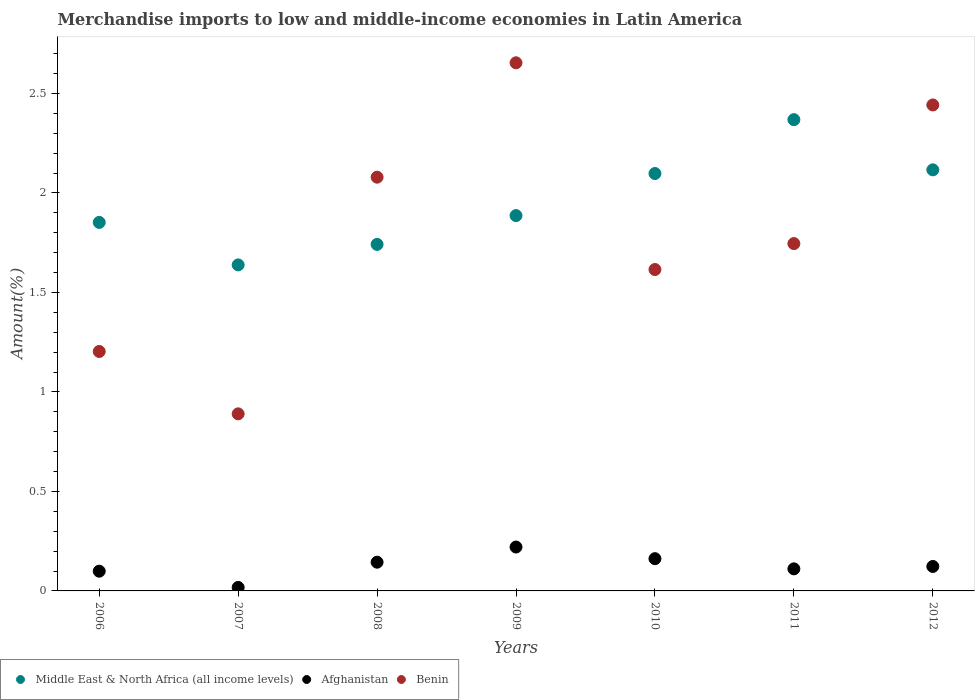How many different coloured dotlines are there?
Your answer should be compact. 3. Is the number of dotlines equal to the number of legend labels?
Make the answer very short. Yes. What is the percentage of amount earned from merchandise imports in Middle East & North Africa (all income levels) in 2006?
Ensure brevity in your answer.  1.85. Across all years, what is the maximum percentage of amount earned from merchandise imports in Afghanistan?
Your response must be concise. 0.22. Across all years, what is the minimum percentage of amount earned from merchandise imports in Afghanistan?
Keep it short and to the point. 0.02. In which year was the percentage of amount earned from merchandise imports in Afghanistan maximum?
Give a very brief answer. 2009. In which year was the percentage of amount earned from merchandise imports in Afghanistan minimum?
Provide a short and direct response. 2007. What is the total percentage of amount earned from merchandise imports in Afghanistan in the graph?
Your answer should be very brief. 0.88. What is the difference between the percentage of amount earned from merchandise imports in Afghanistan in 2008 and that in 2011?
Your response must be concise. 0.03. What is the difference between the percentage of amount earned from merchandise imports in Afghanistan in 2006 and the percentage of amount earned from merchandise imports in Benin in 2007?
Make the answer very short. -0.79. What is the average percentage of amount earned from merchandise imports in Benin per year?
Your answer should be compact. 1.8. In the year 2011, what is the difference between the percentage of amount earned from merchandise imports in Middle East & North Africa (all income levels) and percentage of amount earned from merchandise imports in Afghanistan?
Offer a very short reply. 2.26. In how many years, is the percentage of amount earned from merchandise imports in Middle East & North Africa (all income levels) greater than 1.5 %?
Ensure brevity in your answer.  7. What is the ratio of the percentage of amount earned from merchandise imports in Middle East & North Africa (all income levels) in 2009 to that in 2010?
Provide a succinct answer. 0.9. Is the difference between the percentage of amount earned from merchandise imports in Middle East & North Africa (all income levels) in 2010 and 2012 greater than the difference between the percentage of amount earned from merchandise imports in Afghanistan in 2010 and 2012?
Your answer should be compact. No. What is the difference between the highest and the second highest percentage of amount earned from merchandise imports in Benin?
Provide a succinct answer. 0.21. What is the difference between the highest and the lowest percentage of amount earned from merchandise imports in Middle East & North Africa (all income levels)?
Offer a terse response. 0.73. In how many years, is the percentage of amount earned from merchandise imports in Benin greater than the average percentage of amount earned from merchandise imports in Benin taken over all years?
Offer a very short reply. 3. Is it the case that in every year, the sum of the percentage of amount earned from merchandise imports in Benin and percentage of amount earned from merchandise imports in Middle East & North Africa (all income levels)  is greater than the percentage of amount earned from merchandise imports in Afghanistan?
Keep it short and to the point. Yes. Does the percentage of amount earned from merchandise imports in Benin monotonically increase over the years?
Your answer should be compact. No. Is the percentage of amount earned from merchandise imports in Benin strictly greater than the percentage of amount earned from merchandise imports in Afghanistan over the years?
Offer a terse response. Yes. Is the percentage of amount earned from merchandise imports in Middle East & North Africa (all income levels) strictly less than the percentage of amount earned from merchandise imports in Benin over the years?
Make the answer very short. No. How many dotlines are there?
Provide a succinct answer. 3. What is the difference between two consecutive major ticks on the Y-axis?
Provide a short and direct response. 0.5. Are the values on the major ticks of Y-axis written in scientific E-notation?
Keep it short and to the point. No. Does the graph contain grids?
Make the answer very short. No. Where does the legend appear in the graph?
Provide a short and direct response. Bottom left. How many legend labels are there?
Provide a succinct answer. 3. How are the legend labels stacked?
Provide a succinct answer. Horizontal. What is the title of the graph?
Your answer should be very brief. Merchandise imports to low and middle-income economies in Latin America. What is the label or title of the X-axis?
Your response must be concise. Years. What is the label or title of the Y-axis?
Your answer should be compact. Amount(%). What is the Amount(%) of Middle East & North Africa (all income levels) in 2006?
Your answer should be compact. 1.85. What is the Amount(%) of Afghanistan in 2006?
Provide a succinct answer. 0.1. What is the Amount(%) in Benin in 2006?
Provide a short and direct response. 1.2. What is the Amount(%) of Middle East & North Africa (all income levels) in 2007?
Ensure brevity in your answer.  1.64. What is the Amount(%) in Afghanistan in 2007?
Offer a terse response. 0.02. What is the Amount(%) in Benin in 2007?
Ensure brevity in your answer.  0.89. What is the Amount(%) of Middle East & North Africa (all income levels) in 2008?
Offer a terse response. 1.74. What is the Amount(%) in Afghanistan in 2008?
Provide a succinct answer. 0.14. What is the Amount(%) in Benin in 2008?
Offer a very short reply. 2.08. What is the Amount(%) of Middle East & North Africa (all income levels) in 2009?
Ensure brevity in your answer.  1.89. What is the Amount(%) in Afghanistan in 2009?
Ensure brevity in your answer.  0.22. What is the Amount(%) in Benin in 2009?
Give a very brief answer. 2.65. What is the Amount(%) in Middle East & North Africa (all income levels) in 2010?
Your answer should be compact. 2.1. What is the Amount(%) of Afghanistan in 2010?
Give a very brief answer. 0.16. What is the Amount(%) of Benin in 2010?
Offer a terse response. 1.62. What is the Amount(%) in Middle East & North Africa (all income levels) in 2011?
Your response must be concise. 2.37. What is the Amount(%) in Afghanistan in 2011?
Your answer should be very brief. 0.11. What is the Amount(%) in Benin in 2011?
Provide a succinct answer. 1.75. What is the Amount(%) in Middle East & North Africa (all income levels) in 2012?
Give a very brief answer. 2.12. What is the Amount(%) of Afghanistan in 2012?
Offer a terse response. 0.12. What is the Amount(%) of Benin in 2012?
Your answer should be compact. 2.44. Across all years, what is the maximum Amount(%) of Middle East & North Africa (all income levels)?
Offer a terse response. 2.37. Across all years, what is the maximum Amount(%) of Afghanistan?
Make the answer very short. 0.22. Across all years, what is the maximum Amount(%) in Benin?
Provide a short and direct response. 2.65. Across all years, what is the minimum Amount(%) in Middle East & North Africa (all income levels)?
Your answer should be very brief. 1.64. Across all years, what is the minimum Amount(%) of Afghanistan?
Make the answer very short. 0.02. Across all years, what is the minimum Amount(%) of Benin?
Offer a terse response. 0.89. What is the total Amount(%) in Middle East & North Africa (all income levels) in the graph?
Your response must be concise. 13.7. What is the total Amount(%) of Afghanistan in the graph?
Make the answer very short. 0.88. What is the total Amount(%) in Benin in the graph?
Give a very brief answer. 12.63. What is the difference between the Amount(%) in Middle East & North Africa (all income levels) in 2006 and that in 2007?
Provide a succinct answer. 0.21. What is the difference between the Amount(%) in Afghanistan in 2006 and that in 2007?
Give a very brief answer. 0.08. What is the difference between the Amount(%) of Benin in 2006 and that in 2007?
Provide a short and direct response. 0.31. What is the difference between the Amount(%) in Middle East & North Africa (all income levels) in 2006 and that in 2008?
Make the answer very short. 0.11. What is the difference between the Amount(%) in Afghanistan in 2006 and that in 2008?
Provide a succinct answer. -0.05. What is the difference between the Amount(%) in Benin in 2006 and that in 2008?
Keep it short and to the point. -0.88. What is the difference between the Amount(%) in Middle East & North Africa (all income levels) in 2006 and that in 2009?
Make the answer very short. -0.03. What is the difference between the Amount(%) of Afghanistan in 2006 and that in 2009?
Make the answer very short. -0.12. What is the difference between the Amount(%) in Benin in 2006 and that in 2009?
Keep it short and to the point. -1.45. What is the difference between the Amount(%) in Middle East & North Africa (all income levels) in 2006 and that in 2010?
Give a very brief answer. -0.25. What is the difference between the Amount(%) of Afghanistan in 2006 and that in 2010?
Your response must be concise. -0.06. What is the difference between the Amount(%) in Benin in 2006 and that in 2010?
Offer a very short reply. -0.41. What is the difference between the Amount(%) of Middle East & North Africa (all income levels) in 2006 and that in 2011?
Ensure brevity in your answer.  -0.52. What is the difference between the Amount(%) in Afghanistan in 2006 and that in 2011?
Your answer should be compact. -0.01. What is the difference between the Amount(%) in Benin in 2006 and that in 2011?
Your response must be concise. -0.54. What is the difference between the Amount(%) of Middle East & North Africa (all income levels) in 2006 and that in 2012?
Your answer should be compact. -0.26. What is the difference between the Amount(%) of Afghanistan in 2006 and that in 2012?
Ensure brevity in your answer.  -0.02. What is the difference between the Amount(%) of Benin in 2006 and that in 2012?
Your answer should be compact. -1.24. What is the difference between the Amount(%) in Middle East & North Africa (all income levels) in 2007 and that in 2008?
Your answer should be very brief. -0.1. What is the difference between the Amount(%) of Afghanistan in 2007 and that in 2008?
Keep it short and to the point. -0.13. What is the difference between the Amount(%) of Benin in 2007 and that in 2008?
Provide a short and direct response. -1.19. What is the difference between the Amount(%) of Middle East & North Africa (all income levels) in 2007 and that in 2009?
Ensure brevity in your answer.  -0.25. What is the difference between the Amount(%) in Afghanistan in 2007 and that in 2009?
Provide a short and direct response. -0.2. What is the difference between the Amount(%) in Benin in 2007 and that in 2009?
Your answer should be very brief. -1.76. What is the difference between the Amount(%) in Middle East & North Africa (all income levels) in 2007 and that in 2010?
Your response must be concise. -0.46. What is the difference between the Amount(%) of Afghanistan in 2007 and that in 2010?
Your response must be concise. -0.14. What is the difference between the Amount(%) in Benin in 2007 and that in 2010?
Offer a very short reply. -0.73. What is the difference between the Amount(%) in Middle East & North Africa (all income levels) in 2007 and that in 2011?
Provide a short and direct response. -0.73. What is the difference between the Amount(%) of Afghanistan in 2007 and that in 2011?
Provide a succinct answer. -0.09. What is the difference between the Amount(%) of Benin in 2007 and that in 2011?
Provide a short and direct response. -0.86. What is the difference between the Amount(%) of Middle East & North Africa (all income levels) in 2007 and that in 2012?
Provide a short and direct response. -0.48. What is the difference between the Amount(%) in Afghanistan in 2007 and that in 2012?
Provide a short and direct response. -0.11. What is the difference between the Amount(%) of Benin in 2007 and that in 2012?
Offer a very short reply. -1.55. What is the difference between the Amount(%) in Middle East & North Africa (all income levels) in 2008 and that in 2009?
Your response must be concise. -0.14. What is the difference between the Amount(%) of Afghanistan in 2008 and that in 2009?
Offer a very short reply. -0.08. What is the difference between the Amount(%) of Benin in 2008 and that in 2009?
Make the answer very short. -0.57. What is the difference between the Amount(%) of Middle East & North Africa (all income levels) in 2008 and that in 2010?
Ensure brevity in your answer.  -0.36. What is the difference between the Amount(%) in Afghanistan in 2008 and that in 2010?
Provide a short and direct response. -0.02. What is the difference between the Amount(%) of Benin in 2008 and that in 2010?
Your response must be concise. 0.46. What is the difference between the Amount(%) in Middle East & North Africa (all income levels) in 2008 and that in 2011?
Provide a short and direct response. -0.63. What is the difference between the Amount(%) of Afghanistan in 2008 and that in 2011?
Make the answer very short. 0.03. What is the difference between the Amount(%) of Benin in 2008 and that in 2011?
Provide a succinct answer. 0.33. What is the difference between the Amount(%) in Middle East & North Africa (all income levels) in 2008 and that in 2012?
Keep it short and to the point. -0.37. What is the difference between the Amount(%) of Afghanistan in 2008 and that in 2012?
Your answer should be very brief. 0.02. What is the difference between the Amount(%) of Benin in 2008 and that in 2012?
Provide a short and direct response. -0.36. What is the difference between the Amount(%) of Middle East & North Africa (all income levels) in 2009 and that in 2010?
Provide a succinct answer. -0.21. What is the difference between the Amount(%) in Afghanistan in 2009 and that in 2010?
Keep it short and to the point. 0.06. What is the difference between the Amount(%) in Benin in 2009 and that in 2010?
Your answer should be very brief. 1.04. What is the difference between the Amount(%) in Middle East & North Africa (all income levels) in 2009 and that in 2011?
Ensure brevity in your answer.  -0.48. What is the difference between the Amount(%) of Afghanistan in 2009 and that in 2011?
Ensure brevity in your answer.  0.11. What is the difference between the Amount(%) in Benin in 2009 and that in 2011?
Your answer should be compact. 0.91. What is the difference between the Amount(%) in Middle East & North Africa (all income levels) in 2009 and that in 2012?
Your answer should be very brief. -0.23. What is the difference between the Amount(%) in Afghanistan in 2009 and that in 2012?
Your answer should be very brief. 0.1. What is the difference between the Amount(%) in Benin in 2009 and that in 2012?
Make the answer very short. 0.21. What is the difference between the Amount(%) in Middle East & North Africa (all income levels) in 2010 and that in 2011?
Your answer should be compact. -0.27. What is the difference between the Amount(%) of Afghanistan in 2010 and that in 2011?
Make the answer very short. 0.05. What is the difference between the Amount(%) of Benin in 2010 and that in 2011?
Offer a very short reply. -0.13. What is the difference between the Amount(%) of Middle East & North Africa (all income levels) in 2010 and that in 2012?
Ensure brevity in your answer.  -0.02. What is the difference between the Amount(%) of Afghanistan in 2010 and that in 2012?
Ensure brevity in your answer.  0.04. What is the difference between the Amount(%) in Benin in 2010 and that in 2012?
Provide a short and direct response. -0.83. What is the difference between the Amount(%) of Middle East & North Africa (all income levels) in 2011 and that in 2012?
Ensure brevity in your answer.  0.25. What is the difference between the Amount(%) in Afghanistan in 2011 and that in 2012?
Ensure brevity in your answer.  -0.01. What is the difference between the Amount(%) in Benin in 2011 and that in 2012?
Your answer should be compact. -0.7. What is the difference between the Amount(%) in Middle East & North Africa (all income levels) in 2006 and the Amount(%) in Afghanistan in 2007?
Give a very brief answer. 1.83. What is the difference between the Amount(%) in Afghanistan in 2006 and the Amount(%) in Benin in 2007?
Provide a short and direct response. -0.79. What is the difference between the Amount(%) in Middle East & North Africa (all income levels) in 2006 and the Amount(%) in Afghanistan in 2008?
Ensure brevity in your answer.  1.71. What is the difference between the Amount(%) of Middle East & North Africa (all income levels) in 2006 and the Amount(%) of Benin in 2008?
Your answer should be very brief. -0.23. What is the difference between the Amount(%) in Afghanistan in 2006 and the Amount(%) in Benin in 2008?
Your answer should be very brief. -1.98. What is the difference between the Amount(%) of Middle East & North Africa (all income levels) in 2006 and the Amount(%) of Afghanistan in 2009?
Provide a succinct answer. 1.63. What is the difference between the Amount(%) in Middle East & North Africa (all income levels) in 2006 and the Amount(%) in Benin in 2009?
Provide a short and direct response. -0.8. What is the difference between the Amount(%) in Afghanistan in 2006 and the Amount(%) in Benin in 2009?
Give a very brief answer. -2.55. What is the difference between the Amount(%) of Middle East & North Africa (all income levels) in 2006 and the Amount(%) of Afghanistan in 2010?
Provide a succinct answer. 1.69. What is the difference between the Amount(%) of Middle East & North Africa (all income levels) in 2006 and the Amount(%) of Benin in 2010?
Ensure brevity in your answer.  0.24. What is the difference between the Amount(%) in Afghanistan in 2006 and the Amount(%) in Benin in 2010?
Provide a short and direct response. -1.52. What is the difference between the Amount(%) of Middle East & North Africa (all income levels) in 2006 and the Amount(%) of Afghanistan in 2011?
Ensure brevity in your answer.  1.74. What is the difference between the Amount(%) in Middle East & North Africa (all income levels) in 2006 and the Amount(%) in Benin in 2011?
Provide a short and direct response. 0.11. What is the difference between the Amount(%) in Afghanistan in 2006 and the Amount(%) in Benin in 2011?
Make the answer very short. -1.65. What is the difference between the Amount(%) of Middle East & North Africa (all income levels) in 2006 and the Amount(%) of Afghanistan in 2012?
Your response must be concise. 1.73. What is the difference between the Amount(%) in Middle East & North Africa (all income levels) in 2006 and the Amount(%) in Benin in 2012?
Give a very brief answer. -0.59. What is the difference between the Amount(%) in Afghanistan in 2006 and the Amount(%) in Benin in 2012?
Your answer should be compact. -2.34. What is the difference between the Amount(%) in Middle East & North Africa (all income levels) in 2007 and the Amount(%) in Afghanistan in 2008?
Provide a succinct answer. 1.49. What is the difference between the Amount(%) in Middle East & North Africa (all income levels) in 2007 and the Amount(%) in Benin in 2008?
Offer a terse response. -0.44. What is the difference between the Amount(%) in Afghanistan in 2007 and the Amount(%) in Benin in 2008?
Provide a short and direct response. -2.06. What is the difference between the Amount(%) of Middle East & North Africa (all income levels) in 2007 and the Amount(%) of Afghanistan in 2009?
Ensure brevity in your answer.  1.42. What is the difference between the Amount(%) in Middle East & North Africa (all income levels) in 2007 and the Amount(%) in Benin in 2009?
Offer a very short reply. -1.02. What is the difference between the Amount(%) in Afghanistan in 2007 and the Amount(%) in Benin in 2009?
Keep it short and to the point. -2.64. What is the difference between the Amount(%) of Middle East & North Africa (all income levels) in 2007 and the Amount(%) of Afghanistan in 2010?
Ensure brevity in your answer.  1.48. What is the difference between the Amount(%) of Middle East & North Africa (all income levels) in 2007 and the Amount(%) of Benin in 2010?
Your answer should be very brief. 0.02. What is the difference between the Amount(%) in Afghanistan in 2007 and the Amount(%) in Benin in 2010?
Provide a short and direct response. -1.6. What is the difference between the Amount(%) of Middle East & North Africa (all income levels) in 2007 and the Amount(%) of Afghanistan in 2011?
Ensure brevity in your answer.  1.53. What is the difference between the Amount(%) in Middle East & North Africa (all income levels) in 2007 and the Amount(%) in Benin in 2011?
Provide a short and direct response. -0.11. What is the difference between the Amount(%) of Afghanistan in 2007 and the Amount(%) of Benin in 2011?
Ensure brevity in your answer.  -1.73. What is the difference between the Amount(%) in Middle East & North Africa (all income levels) in 2007 and the Amount(%) in Afghanistan in 2012?
Your answer should be compact. 1.52. What is the difference between the Amount(%) of Middle East & North Africa (all income levels) in 2007 and the Amount(%) of Benin in 2012?
Your response must be concise. -0.8. What is the difference between the Amount(%) of Afghanistan in 2007 and the Amount(%) of Benin in 2012?
Your response must be concise. -2.42. What is the difference between the Amount(%) of Middle East & North Africa (all income levels) in 2008 and the Amount(%) of Afghanistan in 2009?
Your answer should be very brief. 1.52. What is the difference between the Amount(%) in Middle East & North Africa (all income levels) in 2008 and the Amount(%) in Benin in 2009?
Provide a short and direct response. -0.91. What is the difference between the Amount(%) of Afghanistan in 2008 and the Amount(%) of Benin in 2009?
Your answer should be compact. -2.51. What is the difference between the Amount(%) of Middle East & North Africa (all income levels) in 2008 and the Amount(%) of Afghanistan in 2010?
Offer a terse response. 1.58. What is the difference between the Amount(%) in Middle East & North Africa (all income levels) in 2008 and the Amount(%) in Benin in 2010?
Offer a very short reply. 0.13. What is the difference between the Amount(%) in Afghanistan in 2008 and the Amount(%) in Benin in 2010?
Offer a very short reply. -1.47. What is the difference between the Amount(%) in Middle East & North Africa (all income levels) in 2008 and the Amount(%) in Afghanistan in 2011?
Your answer should be compact. 1.63. What is the difference between the Amount(%) in Middle East & North Africa (all income levels) in 2008 and the Amount(%) in Benin in 2011?
Provide a short and direct response. -0. What is the difference between the Amount(%) in Afghanistan in 2008 and the Amount(%) in Benin in 2011?
Offer a very short reply. -1.6. What is the difference between the Amount(%) of Middle East & North Africa (all income levels) in 2008 and the Amount(%) of Afghanistan in 2012?
Your answer should be very brief. 1.62. What is the difference between the Amount(%) in Middle East & North Africa (all income levels) in 2008 and the Amount(%) in Benin in 2012?
Your answer should be very brief. -0.7. What is the difference between the Amount(%) in Afghanistan in 2008 and the Amount(%) in Benin in 2012?
Ensure brevity in your answer.  -2.3. What is the difference between the Amount(%) in Middle East & North Africa (all income levels) in 2009 and the Amount(%) in Afghanistan in 2010?
Provide a succinct answer. 1.72. What is the difference between the Amount(%) in Middle East & North Africa (all income levels) in 2009 and the Amount(%) in Benin in 2010?
Provide a short and direct response. 0.27. What is the difference between the Amount(%) in Afghanistan in 2009 and the Amount(%) in Benin in 2010?
Provide a succinct answer. -1.39. What is the difference between the Amount(%) of Middle East & North Africa (all income levels) in 2009 and the Amount(%) of Afghanistan in 2011?
Provide a succinct answer. 1.78. What is the difference between the Amount(%) of Middle East & North Africa (all income levels) in 2009 and the Amount(%) of Benin in 2011?
Provide a succinct answer. 0.14. What is the difference between the Amount(%) of Afghanistan in 2009 and the Amount(%) of Benin in 2011?
Keep it short and to the point. -1.52. What is the difference between the Amount(%) of Middle East & North Africa (all income levels) in 2009 and the Amount(%) of Afghanistan in 2012?
Offer a terse response. 1.76. What is the difference between the Amount(%) of Middle East & North Africa (all income levels) in 2009 and the Amount(%) of Benin in 2012?
Provide a short and direct response. -0.56. What is the difference between the Amount(%) in Afghanistan in 2009 and the Amount(%) in Benin in 2012?
Your answer should be compact. -2.22. What is the difference between the Amount(%) of Middle East & North Africa (all income levels) in 2010 and the Amount(%) of Afghanistan in 2011?
Ensure brevity in your answer.  1.99. What is the difference between the Amount(%) of Middle East & North Africa (all income levels) in 2010 and the Amount(%) of Benin in 2011?
Make the answer very short. 0.35. What is the difference between the Amount(%) in Afghanistan in 2010 and the Amount(%) in Benin in 2011?
Offer a terse response. -1.58. What is the difference between the Amount(%) in Middle East & North Africa (all income levels) in 2010 and the Amount(%) in Afghanistan in 2012?
Your answer should be compact. 1.97. What is the difference between the Amount(%) in Middle East & North Africa (all income levels) in 2010 and the Amount(%) in Benin in 2012?
Ensure brevity in your answer.  -0.34. What is the difference between the Amount(%) in Afghanistan in 2010 and the Amount(%) in Benin in 2012?
Offer a terse response. -2.28. What is the difference between the Amount(%) in Middle East & North Africa (all income levels) in 2011 and the Amount(%) in Afghanistan in 2012?
Offer a very short reply. 2.25. What is the difference between the Amount(%) in Middle East & North Africa (all income levels) in 2011 and the Amount(%) in Benin in 2012?
Your answer should be very brief. -0.07. What is the difference between the Amount(%) of Afghanistan in 2011 and the Amount(%) of Benin in 2012?
Offer a very short reply. -2.33. What is the average Amount(%) of Middle East & North Africa (all income levels) per year?
Keep it short and to the point. 1.96. What is the average Amount(%) of Afghanistan per year?
Your response must be concise. 0.13. What is the average Amount(%) in Benin per year?
Your answer should be very brief. 1.8. In the year 2006, what is the difference between the Amount(%) in Middle East & North Africa (all income levels) and Amount(%) in Afghanistan?
Your answer should be compact. 1.75. In the year 2006, what is the difference between the Amount(%) in Middle East & North Africa (all income levels) and Amount(%) in Benin?
Offer a terse response. 0.65. In the year 2006, what is the difference between the Amount(%) of Afghanistan and Amount(%) of Benin?
Your response must be concise. -1.1. In the year 2007, what is the difference between the Amount(%) in Middle East & North Africa (all income levels) and Amount(%) in Afghanistan?
Offer a terse response. 1.62. In the year 2007, what is the difference between the Amount(%) of Middle East & North Africa (all income levels) and Amount(%) of Benin?
Ensure brevity in your answer.  0.75. In the year 2007, what is the difference between the Amount(%) in Afghanistan and Amount(%) in Benin?
Make the answer very short. -0.87. In the year 2008, what is the difference between the Amount(%) of Middle East & North Africa (all income levels) and Amount(%) of Afghanistan?
Give a very brief answer. 1.6. In the year 2008, what is the difference between the Amount(%) in Middle East & North Africa (all income levels) and Amount(%) in Benin?
Keep it short and to the point. -0.34. In the year 2008, what is the difference between the Amount(%) of Afghanistan and Amount(%) of Benin?
Provide a short and direct response. -1.93. In the year 2009, what is the difference between the Amount(%) of Middle East & North Africa (all income levels) and Amount(%) of Afghanistan?
Your response must be concise. 1.67. In the year 2009, what is the difference between the Amount(%) of Middle East & North Africa (all income levels) and Amount(%) of Benin?
Keep it short and to the point. -0.77. In the year 2009, what is the difference between the Amount(%) in Afghanistan and Amount(%) in Benin?
Offer a very short reply. -2.43. In the year 2010, what is the difference between the Amount(%) of Middle East & North Africa (all income levels) and Amount(%) of Afghanistan?
Your response must be concise. 1.94. In the year 2010, what is the difference between the Amount(%) of Middle East & North Africa (all income levels) and Amount(%) of Benin?
Your response must be concise. 0.48. In the year 2010, what is the difference between the Amount(%) in Afghanistan and Amount(%) in Benin?
Your answer should be very brief. -1.45. In the year 2011, what is the difference between the Amount(%) in Middle East & North Africa (all income levels) and Amount(%) in Afghanistan?
Offer a very short reply. 2.26. In the year 2011, what is the difference between the Amount(%) in Middle East & North Africa (all income levels) and Amount(%) in Benin?
Provide a short and direct response. 0.62. In the year 2011, what is the difference between the Amount(%) of Afghanistan and Amount(%) of Benin?
Make the answer very short. -1.63. In the year 2012, what is the difference between the Amount(%) of Middle East & North Africa (all income levels) and Amount(%) of Afghanistan?
Offer a very short reply. 1.99. In the year 2012, what is the difference between the Amount(%) in Middle East & North Africa (all income levels) and Amount(%) in Benin?
Your answer should be very brief. -0.33. In the year 2012, what is the difference between the Amount(%) in Afghanistan and Amount(%) in Benin?
Ensure brevity in your answer.  -2.32. What is the ratio of the Amount(%) in Middle East & North Africa (all income levels) in 2006 to that in 2007?
Offer a very short reply. 1.13. What is the ratio of the Amount(%) in Afghanistan in 2006 to that in 2007?
Provide a succinct answer. 5.65. What is the ratio of the Amount(%) in Benin in 2006 to that in 2007?
Your answer should be compact. 1.35. What is the ratio of the Amount(%) of Middle East & North Africa (all income levels) in 2006 to that in 2008?
Provide a succinct answer. 1.06. What is the ratio of the Amount(%) of Afghanistan in 2006 to that in 2008?
Provide a short and direct response. 0.69. What is the ratio of the Amount(%) of Benin in 2006 to that in 2008?
Offer a terse response. 0.58. What is the ratio of the Amount(%) of Middle East & North Africa (all income levels) in 2006 to that in 2009?
Provide a succinct answer. 0.98. What is the ratio of the Amount(%) of Afghanistan in 2006 to that in 2009?
Provide a short and direct response. 0.45. What is the ratio of the Amount(%) of Benin in 2006 to that in 2009?
Your answer should be very brief. 0.45. What is the ratio of the Amount(%) in Middle East & North Africa (all income levels) in 2006 to that in 2010?
Give a very brief answer. 0.88. What is the ratio of the Amount(%) of Afghanistan in 2006 to that in 2010?
Offer a very short reply. 0.61. What is the ratio of the Amount(%) in Benin in 2006 to that in 2010?
Offer a terse response. 0.74. What is the ratio of the Amount(%) in Middle East & North Africa (all income levels) in 2006 to that in 2011?
Provide a succinct answer. 0.78. What is the ratio of the Amount(%) of Afghanistan in 2006 to that in 2011?
Provide a short and direct response. 0.89. What is the ratio of the Amount(%) in Benin in 2006 to that in 2011?
Your response must be concise. 0.69. What is the ratio of the Amount(%) in Middle East & North Africa (all income levels) in 2006 to that in 2012?
Ensure brevity in your answer.  0.88. What is the ratio of the Amount(%) in Afghanistan in 2006 to that in 2012?
Provide a succinct answer. 0.81. What is the ratio of the Amount(%) in Benin in 2006 to that in 2012?
Ensure brevity in your answer.  0.49. What is the ratio of the Amount(%) in Middle East & North Africa (all income levels) in 2007 to that in 2008?
Offer a very short reply. 0.94. What is the ratio of the Amount(%) in Afghanistan in 2007 to that in 2008?
Provide a succinct answer. 0.12. What is the ratio of the Amount(%) of Benin in 2007 to that in 2008?
Your answer should be compact. 0.43. What is the ratio of the Amount(%) in Middle East & North Africa (all income levels) in 2007 to that in 2009?
Keep it short and to the point. 0.87. What is the ratio of the Amount(%) of Afghanistan in 2007 to that in 2009?
Offer a very short reply. 0.08. What is the ratio of the Amount(%) in Benin in 2007 to that in 2009?
Give a very brief answer. 0.34. What is the ratio of the Amount(%) of Middle East & North Africa (all income levels) in 2007 to that in 2010?
Provide a succinct answer. 0.78. What is the ratio of the Amount(%) in Afghanistan in 2007 to that in 2010?
Offer a terse response. 0.11. What is the ratio of the Amount(%) of Benin in 2007 to that in 2010?
Ensure brevity in your answer.  0.55. What is the ratio of the Amount(%) of Middle East & North Africa (all income levels) in 2007 to that in 2011?
Provide a short and direct response. 0.69. What is the ratio of the Amount(%) of Afghanistan in 2007 to that in 2011?
Give a very brief answer. 0.16. What is the ratio of the Amount(%) in Benin in 2007 to that in 2011?
Your answer should be compact. 0.51. What is the ratio of the Amount(%) of Middle East & North Africa (all income levels) in 2007 to that in 2012?
Your answer should be compact. 0.77. What is the ratio of the Amount(%) in Afghanistan in 2007 to that in 2012?
Provide a succinct answer. 0.14. What is the ratio of the Amount(%) in Benin in 2007 to that in 2012?
Make the answer very short. 0.36. What is the ratio of the Amount(%) of Middle East & North Africa (all income levels) in 2008 to that in 2009?
Make the answer very short. 0.92. What is the ratio of the Amount(%) in Afghanistan in 2008 to that in 2009?
Your response must be concise. 0.65. What is the ratio of the Amount(%) in Benin in 2008 to that in 2009?
Ensure brevity in your answer.  0.78. What is the ratio of the Amount(%) in Middle East & North Africa (all income levels) in 2008 to that in 2010?
Your answer should be compact. 0.83. What is the ratio of the Amount(%) in Afghanistan in 2008 to that in 2010?
Provide a short and direct response. 0.89. What is the ratio of the Amount(%) of Benin in 2008 to that in 2010?
Your answer should be very brief. 1.29. What is the ratio of the Amount(%) of Middle East & North Africa (all income levels) in 2008 to that in 2011?
Provide a short and direct response. 0.74. What is the ratio of the Amount(%) in Afghanistan in 2008 to that in 2011?
Provide a short and direct response. 1.3. What is the ratio of the Amount(%) of Benin in 2008 to that in 2011?
Make the answer very short. 1.19. What is the ratio of the Amount(%) of Middle East & North Africa (all income levels) in 2008 to that in 2012?
Give a very brief answer. 0.82. What is the ratio of the Amount(%) of Afghanistan in 2008 to that in 2012?
Make the answer very short. 1.17. What is the ratio of the Amount(%) of Benin in 2008 to that in 2012?
Your response must be concise. 0.85. What is the ratio of the Amount(%) of Middle East & North Africa (all income levels) in 2009 to that in 2010?
Ensure brevity in your answer.  0.9. What is the ratio of the Amount(%) in Afghanistan in 2009 to that in 2010?
Keep it short and to the point. 1.36. What is the ratio of the Amount(%) of Benin in 2009 to that in 2010?
Your response must be concise. 1.64. What is the ratio of the Amount(%) in Middle East & North Africa (all income levels) in 2009 to that in 2011?
Your answer should be compact. 0.8. What is the ratio of the Amount(%) of Afghanistan in 2009 to that in 2011?
Your response must be concise. 1.99. What is the ratio of the Amount(%) in Benin in 2009 to that in 2011?
Keep it short and to the point. 1.52. What is the ratio of the Amount(%) of Middle East & North Africa (all income levels) in 2009 to that in 2012?
Offer a very short reply. 0.89. What is the ratio of the Amount(%) of Afghanistan in 2009 to that in 2012?
Offer a very short reply. 1.79. What is the ratio of the Amount(%) of Benin in 2009 to that in 2012?
Keep it short and to the point. 1.09. What is the ratio of the Amount(%) of Middle East & North Africa (all income levels) in 2010 to that in 2011?
Your response must be concise. 0.89. What is the ratio of the Amount(%) in Afghanistan in 2010 to that in 2011?
Offer a very short reply. 1.46. What is the ratio of the Amount(%) in Benin in 2010 to that in 2011?
Make the answer very short. 0.93. What is the ratio of the Amount(%) of Middle East & North Africa (all income levels) in 2010 to that in 2012?
Your answer should be compact. 0.99. What is the ratio of the Amount(%) in Afghanistan in 2010 to that in 2012?
Offer a terse response. 1.32. What is the ratio of the Amount(%) in Benin in 2010 to that in 2012?
Offer a terse response. 0.66. What is the ratio of the Amount(%) of Middle East & North Africa (all income levels) in 2011 to that in 2012?
Offer a very short reply. 1.12. What is the ratio of the Amount(%) of Afghanistan in 2011 to that in 2012?
Offer a very short reply. 0.9. What is the ratio of the Amount(%) of Benin in 2011 to that in 2012?
Your response must be concise. 0.71. What is the difference between the highest and the second highest Amount(%) in Middle East & North Africa (all income levels)?
Make the answer very short. 0.25. What is the difference between the highest and the second highest Amount(%) of Afghanistan?
Your answer should be compact. 0.06. What is the difference between the highest and the second highest Amount(%) of Benin?
Offer a terse response. 0.21. What is the difference between the highest and the lowest Amount(%) of Middle East & North Africa (all income levels)?
Ensure brevity in your answer.  0.73. What is the difference between the highest and the lowest Amount(%) of Afghanistan?
Your answer should be very brief. 0.2. What is the difference between the highest and the lowest Amount(%) of Benin?
Offer a terse response. 1.76. 